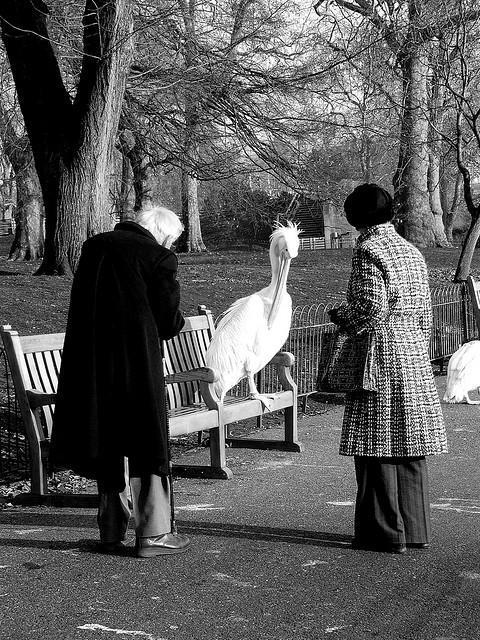What is the bird on the bench called? Please explain your reasoning. stork. The bird represents babies. 